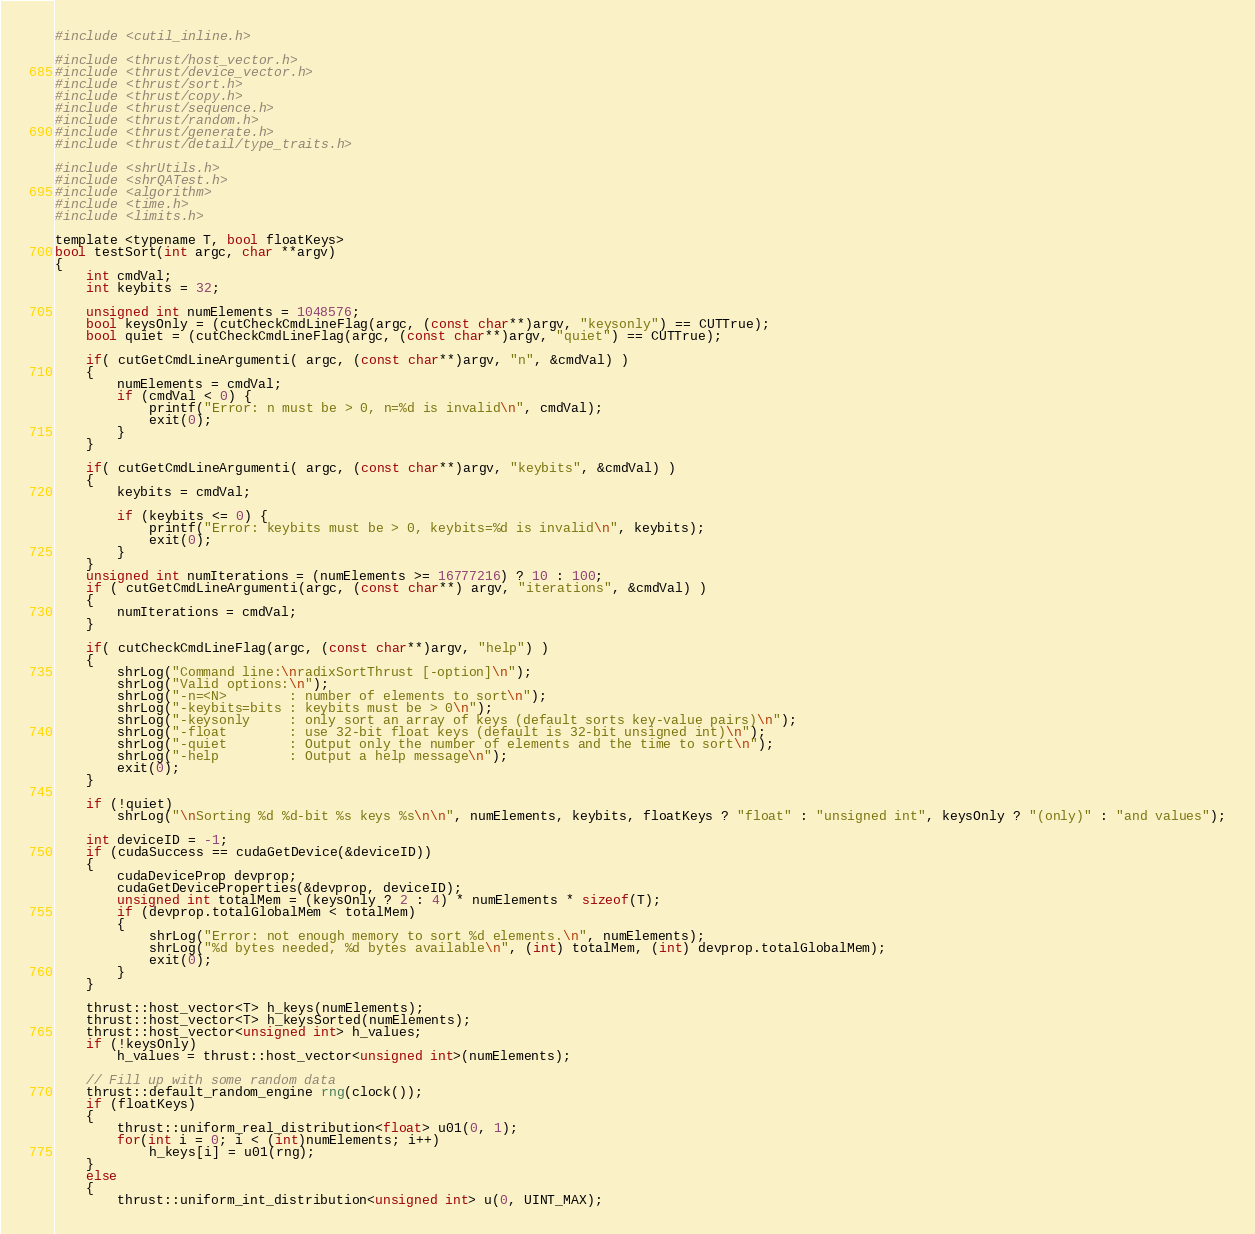Convert code to text. <code><loc_0><loc_0><loc_500><loc_500><_Cuda_>

#include <cutil_inline.h>

#include <thrust/host_vector.h>
#include <thrust/device_vector.h>
#include <thrust/sort.h>
#include <thrust/copy.h>
#include <thrust/sequence.h>
#include <thrust/random.h>
#include <thrust/generate.h>
#include <thrust/detail/type_traits.h>

#include <shrUtils.h>
#include <shrQATest.h>
#include <algorithm>
#include <time.h>
#include <limits.h>

template <typename T, bool floatKeys>
bool testSort(int argc, char **argv)
{
    int cmdVal;
    int keybits = 32;

    unsigned int numElements = 1048576;
    bool keysOnly = (cutCheckCmdLineFlag(argc, (const char**)argv, "keysonly") == CUTTrue);
    bool quiet = (cutCheckCmdLineFlag(argc, (const char**)argv, "quiet") == CUTTrue);

    if( cutGetCmdLineArgumenti( argc, (const char**)argv, "n", &cmdVal) )
    { 
        numElements = cmdVal;
		if (cmdVal < 0) {
		    printf("Error: n must be > 0, n=%d is invalid\n", cmdVal);
			exit(0);
		}
    }

    if( cutGetCmdLineArgumenti( argc, (const char**)argv, "keybits", &cmdVal) )
    {
        keybits = cmdVal;
        
        if (keybits <= 0) {
			printf("Error: keybits must be > 0, keybits=%d is invalid\n", keybits);
			exit(0);
        }
    }
    unsigned int numIterations = (numElements >= 16777216) ? 10 : 100;
    if ( cutGetCmdLineArgumenti(argc, (const char**) argv, "iterations", &cmdVal) )
    {
        numIterations = cmdVal;
    }

    if( cutCheckCmdLineFlag(argc, (const char**)argv, "help") )
    {
        shrLog("Command line:\nradixSortThrust [-option]\n");
        shrLog("Valid options:\n");
        shrLog("-n=<N>        : number of elements to sort\n");
        shrLog("-keybits=bits : keybits must be > 0\n");
        shrLog("-keysonly     : only sort an array of keys (default sorts key-value pairs)\n");
        shrLog("-float        : use 32-bit float keys (default is 32-bit unsigned int)\n");
        shrLog("-quiet        : Output only the number of elements and the time to sort\n");
        shrLog("-help         : Output a help message\n");
        exit(0);
    }

    if (!quiet)
        shrLog("\nSorting %d %d-bit %s keys %s\n\n", numElements, keybits, floatKeys ? "float" : "unsigned int", keysOnly ? "(only)" : "and values");

    int deviceID = -1;
    if (cudaSuccess == cudaGetDevice(&deviceID))
    {
        cudaDeviceProp devprop;
        cudaGetDeviceProperties(&devprop, deviceID);
        unsigned int totalMem = (keysOnly ? 2 : 4) * numElements * sizeof(T);
        if (devprop.totalGlobalMem < totalMem)
        {
            shrLog("Error: not enough memory to sort %d elements.\n", numElements);
            shrLog("%d bytes needed, %d bytes available\n", (int) totalMem, (int) devprop.totalGlobalMem);
            exit(0);
        }
    }

    thrust::host_vector<T> h_keys(numElements);
    thrust::host_vector<T> h_keysSorted(numElements);
    thrust::host_vector<unsigned int> h_values;
    if (!keysOnly)
        h_values = thrust::host_vector<unsigned int>(numElements);

    // Fill up with some random data
    thrust::default_random_engine rng(clock());
    if (floatKeys)
    {
        thrust::uniform_real_distribution<float> u01(0, 1);
        for(int i = 0; i < (int)numElements; i++)
            h_keys[i] = u01(rng);
    }
    else
    {
        thrust::uniform_int_distribution<unsigned int> u(0, UINT_MAX);</code> 